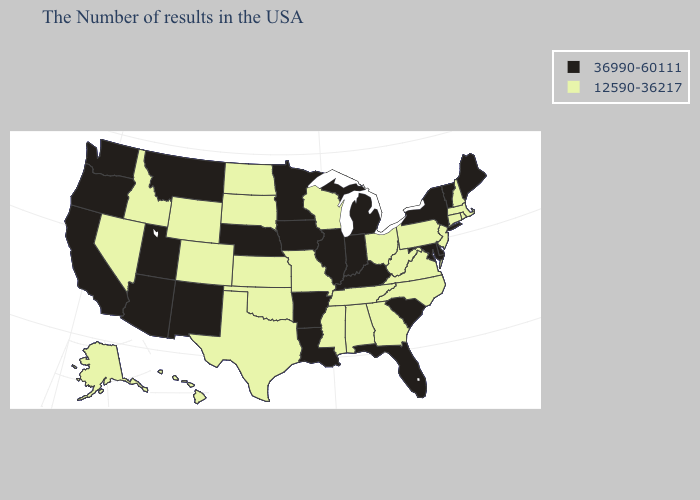Among the states that border South Carolina , which have the lowest value?
Give a very brief answer. North Carolina, Georgia. Does Minnesota have the same value as Connecticut?
Concise answer only. No. What is the value of Colorado?
Short answer required. 12590-36217. What is the value of Oregon?
Concise answer only. 36990-60111. What is the value of Utah?
Be succinct. 36990-60111. Does North Dakota have the highest value in the MidWest?
Write a very short answer. No. Name the states that have a value in the range 12590-36217?
Concise answer only. Massachusetts, Rhode Island, New Hampshire, Connecticut, New Jersey, Pennsylvania, Virginia, North Carolina, West Virginia, Ohio, Georgia, Alabama, Tennessee, Wisconsin, Mississippi, Missouri, Kansas, Oklahoma, Texas, South Dakota, North Dakota, Wyoming, Colorado, Idaho, Nevada, Alaska, Hawaii. What is the value of Illinois?
Concise answer only. 36990-60111. Name the states that have a value in the range 36990-60111?
Give a very brief answer. Maine, Vermont, New York, Delaware, Maryland, South Carolina, Florida, Michigan, Kentucky, Indiana, Illinois, Louisiana, Arkansas, Minnesota, Iowa, Nebraska, New Mexico, Utah, Montana, Arizona, California, Washington, Oregon. Does North Carolina have a lower value than Illinois?
Keep it brief. Yes. What is the lowest value in the USA?
Write a very short answer. 12590-36217. What is the value of North Dakota?
Concise answer only. 12590-36217. How many symbols are there in the legend?
Concise answer only. 2. Which states have the lowest value in the USA?
Quick response, please. Massachusetts, Rhode Island, New Hampshire, Connecticut, New Jersey, Pennsylvania, Virginia, North Carolina, West Virginia, Ohio, Georgia, Alabama, Tennessee, Wisconsin, Mississippi, Missouri, Kansas, Oklahoma, Texas, South Dakota, North Dakota, Wyoming, Colorado, Idaho, Nevada, Alaska, Hawaii. What is the value of Maine?
Keep it brief. 36990-60111. 